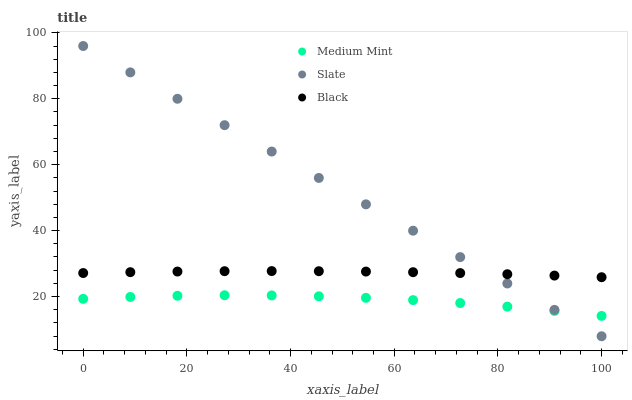Does Medium Mint have the minimum area under the curve?
Answer yes or no. Yes. Does Slate have the maximum area under the curve?
Answer yes or no. Yes. Does Black have the minimum area under the curve?
Answer yes or no. No. Does Black have the maximum area under the curve?
Answer yes or no. No. Is Slate the smoothest?
Answer yes or no. Yes. Is Medium Mint the roughest?
Answer yes or no. Yes. Is Black the smoothest?
Answer yes or no. No. Is Black the roughest?
Answer yes or no. No. Does Slate have the lowest value?
Answer yes or no. Yes. Does Black have the lowest value?
Answer yes or no. No. Does Slate have the highest value?
Answer yes or no. Yes. Does Black have the highest value?
Answer yes or no. No. Is Medium Mint less than Black?
Answer yes or no. Yes. Is Black greater than Medium Mint?
Answer yes or no. Yes. Does Slate intersect Black?
Answer yes or no. Yes. Is Slate less than Black?
Answer yes or no. No. Is Slate greater than Black?
Answer yes or no. No. Does Medium Mint intersect Black?
Answer yes or no. No. 